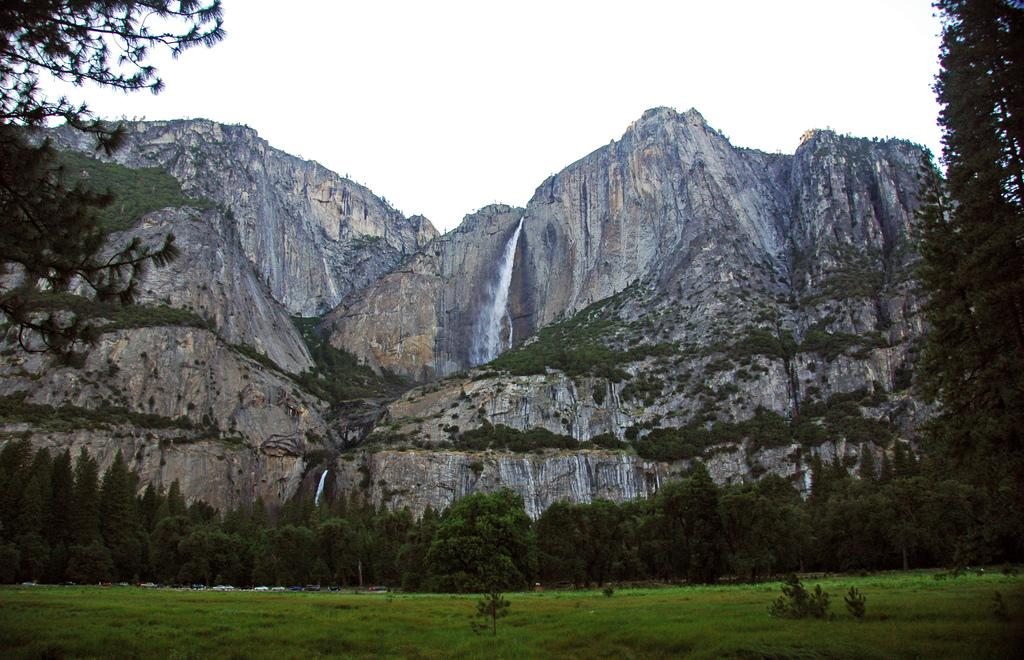What type of vegetation can be seen in the image? There are trees and grass in the image. What natural features are visible in the background of the image? There are mountains, water, and the sky visible in the background of the image. What type of music can be heard coming from the trees in the image? There is no music present in the image, as it features trees, grass, mountains, water, and the sky. 